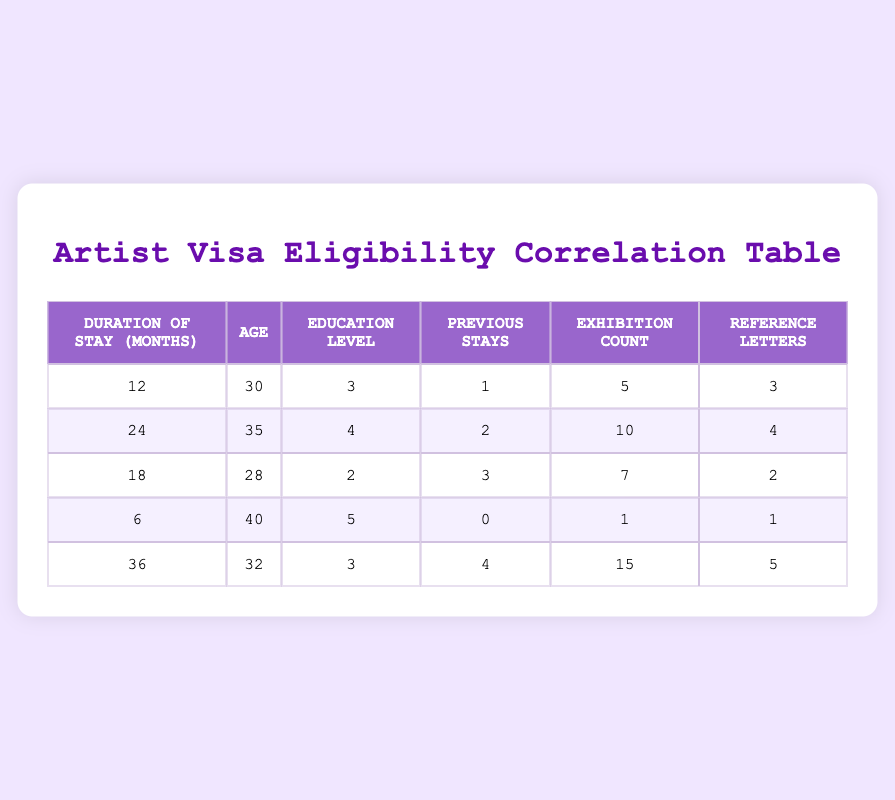What is the duration of stay for the artist with the most exhibition counts? The artist with the highest exhibition count has 15 exhibitions, which corresponds to the artist with a duration of stay of 36 months.
Answer: 36 months How many reference letters does the youngest artist have? The youngest artist is 28 years old, which corresponds to the artist with 2 reference letters.
Answer: 2 Is there an artist with no previous stays who has a high education level? The artist with no previous stays has an education level of 5, which is considered high.
Answer: Yes What is the average duration of stay among the artists? To find the average, add the durations of stay: 12 + 24 + 18 + 6 + 36 = 96 months. Then, divide by the number of artists (5), which results in an average of 96 / 5 = 19.2 months.
Answer: 19.2 months Do older artists tend to have more reference letters? The average age of artists with fewer reference letters (1-2) is higher than those with more reference letters (3-5), indicating older artists do not tend to have more reference letters.
Answer: No What is the maximum exhibition count recorded in the table? The maximum exhibition count listed in the table is 15, which corresponds to the artist with a duration of stay of 36 months.
Answer: 15 How does the average age of artists with more than 3 reference letters compare to those with fewer? The average age of artists with more than 3 reference letters (30 and 32) is (30 + 32) / 2 = 31 years. The average age of artists with 3 or fewer reference letters is (35 + 28 + 40) / 3 = 34.33 years. Since 31 is lower than 34.33, artists with more reference letters are generally younger.
Answer: Younger What is the median education level of all artists? When arranged in order (2, 3, 3, 4, 5), the middle value (median) is 3, found by identifying the central point in the ordered list of education levels.
Answer: 3 